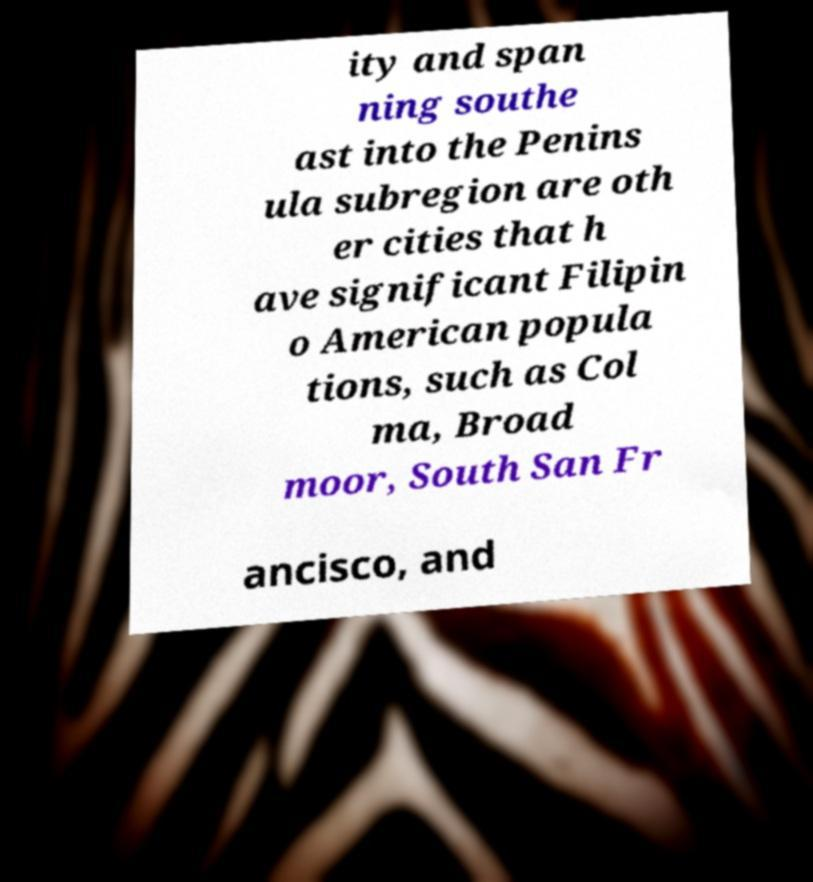Could you extract and type out the text from this image? ity and span ning southe ast into the Penins ula subregion are oth er cities that h ave significant Filipin o American popula tions, such as Col ma, Broad moor, South San Fr ancisco, and 